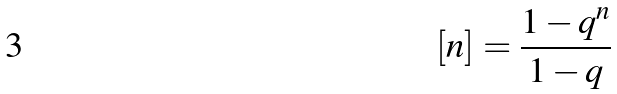<formula> <loc_0><loc_0><loc_500><loc_500>[ n ] = \frac { 1 - q ^ { n } } { 1 - q }</formula> 